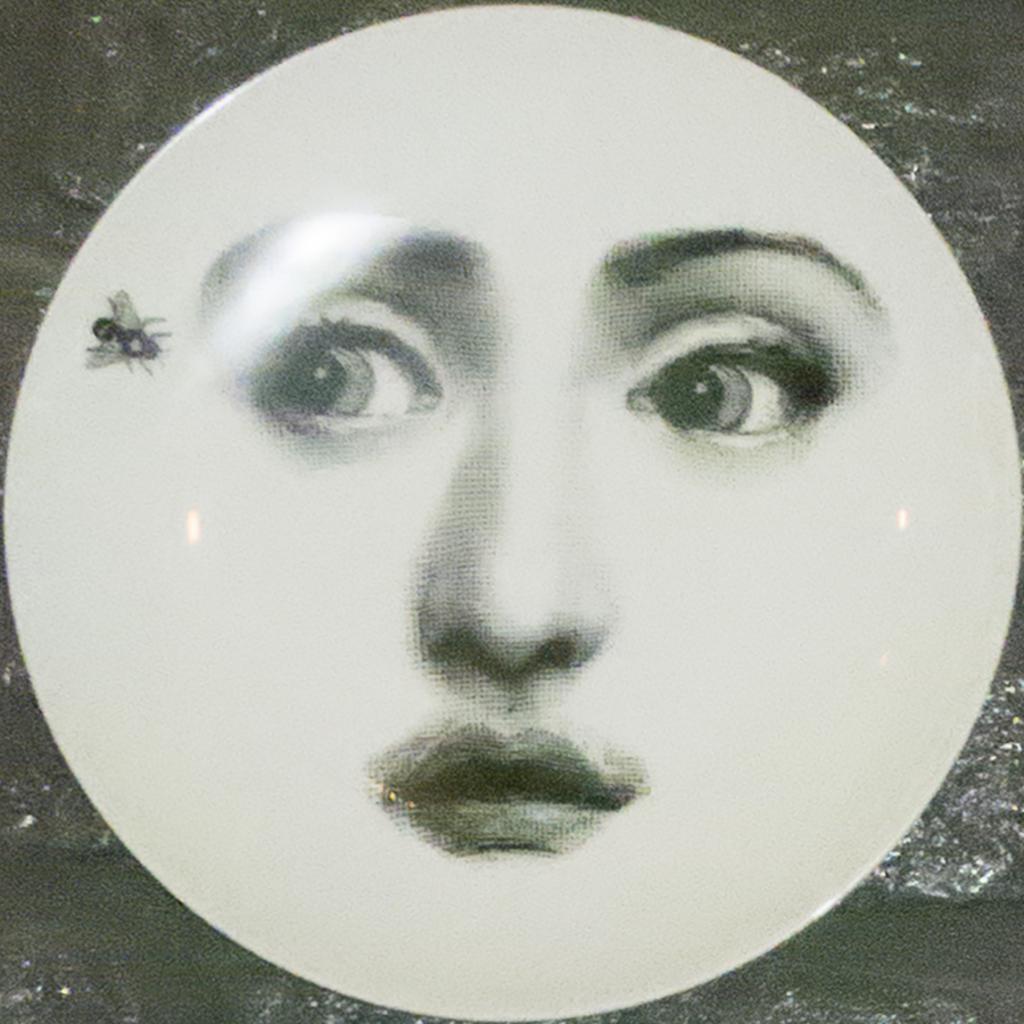How would you summarize this image in a sentence or two? In this image there is a painting on the plate having an insect on it. Two eyes, nose and a mouth are painted on the plate. 